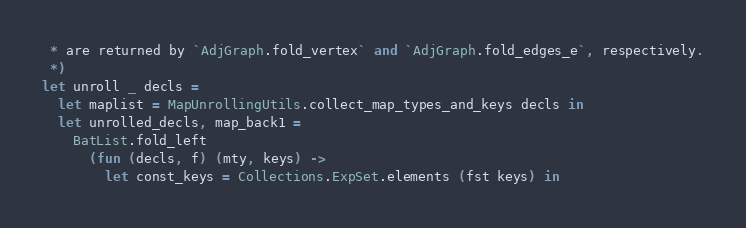<code> <loc_0><loc_0><loc_500><loc_500><_OCaml_> * are returned by `AdjGraph.fold_vertex` and `AdjGraph.fold_edges_e`, respectively.
 *)
let unroll _ decls =
  let maplist = MapUnrollingUtils.collect_map_types_and_keys decls in
  let unrolled_decls, map_back1 =
    BatList.fold_left
      (fun (decls, f) (mty, keys) ->
        let const_keys = Collections.ExpSet.elements (fst keys) in</code> 